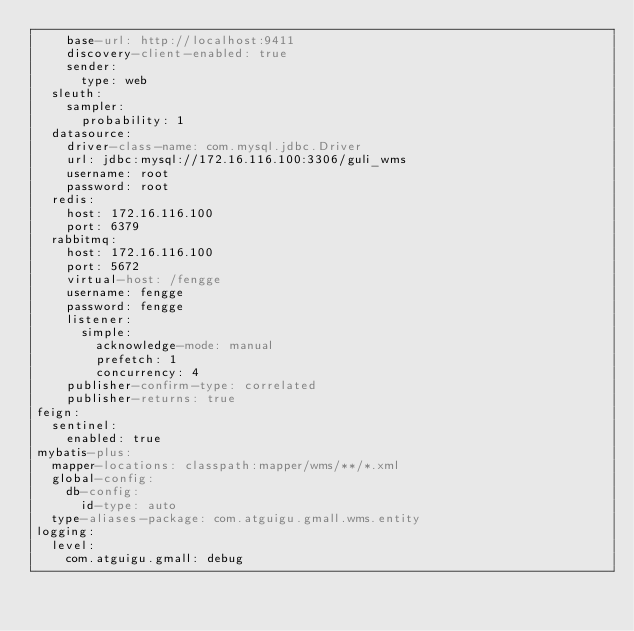<code> <loc_0><loc_0><loc_500><loc_500><_YAML_>    base-url: http://localhost:9411
    discovery-client-enabled: true
    sender:
      type: web
  sleuth:
    sampler:
      probability: 1
  datasource:
    driver-class-name: com.mysql.jdbc.Driver
    url: jdbc:mysql://172.16.116.100:3306/guli_wms
    username: root
    password: root
  redis:
    host: 172.16.116.100
    port: 6379
  rabbitmq:
    host: 172.16.116.100
    port: 5672
    virtual-host: /fengge
    username: fengge
    password: fengge
    listener:
      simple:
        acknowledge-mode: manual
        prefetch: 1
        concurrency: 4
    publisher-confirm-type: correlated
    publisher-returns: true
feign:
  sentinel:
    enabled: true
mybatis-plus:
  mapper-locations: classpath:mapper/wms/**/*.xml
  global-config:
    db-config:
      id-type: auto
  type-aliases-package: com.atguigu.gmall.wms.entity
logging:
  level:
    com.atguigu.gmall: debug</code> 